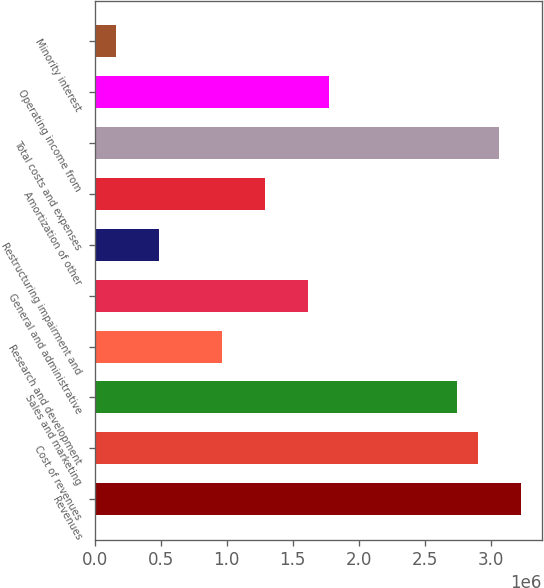Convert chart to OTSL. <chart><loc_0><loc_0><loc_500><loc_500><bar_chart><fcel>Revenues<fcel>Cost of revenues<fcel>Sales and marketing<fcel>Research and development<fcel>General and administrative<fcel>Restructuring impairment and<fcel>Amortization of other<fcel>Total costs and expenses<fcel>Operating income from<fcel>Minority interest<nl><fcel>3.22515e+06<fcel>2.90263e+06<fcel>2.74138e+06<fcel>967545<fcel>1.61257e+06<fcel>483773<fcel>1.29006e+06<fcel>3.06389e+06<fcel>1.77383e+06<fcel>161258<nl></chart> 